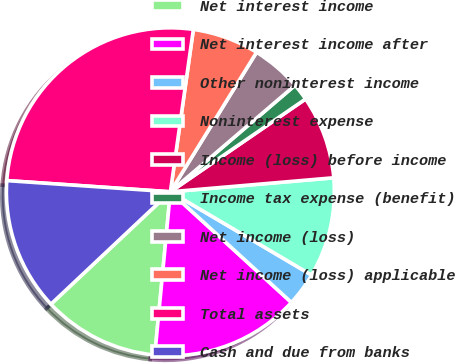<chart> <loc_0><loc_0><loc_500><loc_500><pie_chart><fcel>Net interest income<fcel>Net interest income after<fcel>Other noninterest income<fcel>Noninterest expense<fcel>Income (loss) before income<fcel>Income tax expense (benefit)<fcel>Net income (loss)<fcel>Net income (loss) applicable<fcel>Total assets<fcel>Cash and due from banks<nl><fcel>11.47%<fcel>14.73%<fcel>3.31%<fcel>9.84%<fcel>8.21%<fcel>1.68%<fcel>4.94%<fcel>6.57%<fcel>26.15%<fcel>13.1%<nl></chart> 